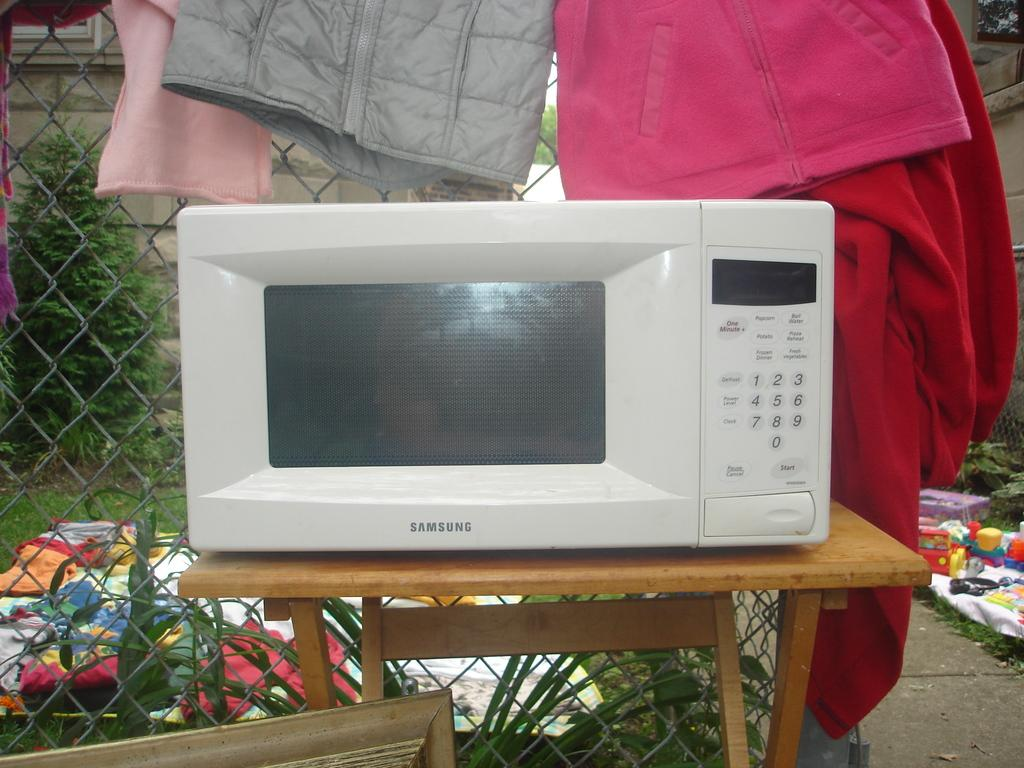Provide a one-sentence caption for the provided image. A white microwave on a table, and the microwave is by Samsung. 